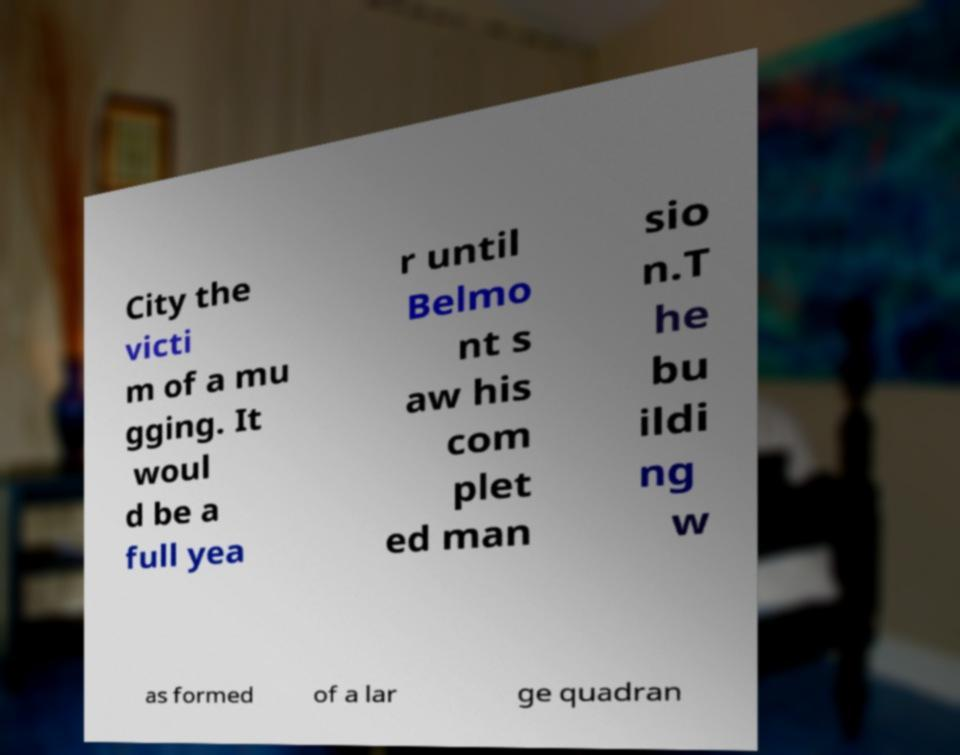There's text embedded in this image that I need extracted. Can you transcribe it verbatim? City the victi m of a mu gging. It woul d be a full yea r until Belmo nt s aw his com plet ed man sio n.T he bu ildi ng w as formed of a lar ge quadran 